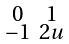Convert formula to latex. <formula><loc_0><loc_0><loc_500><loc_500>\begin{smallmatrix} 0 & 1 \\ - 1 & 2 u \end{smallmatrix}</formula> 